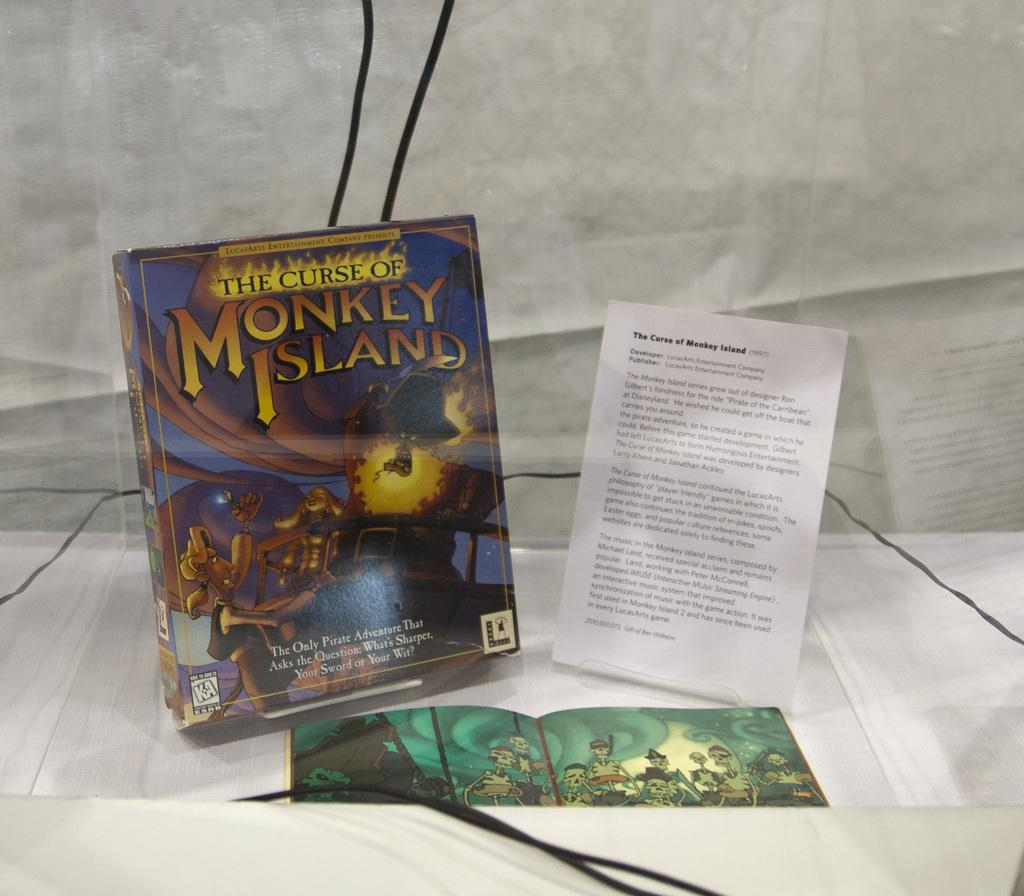Provide a one-sentence caption for the provided image. a couple of books on a surface and one which says Monkey Island. 